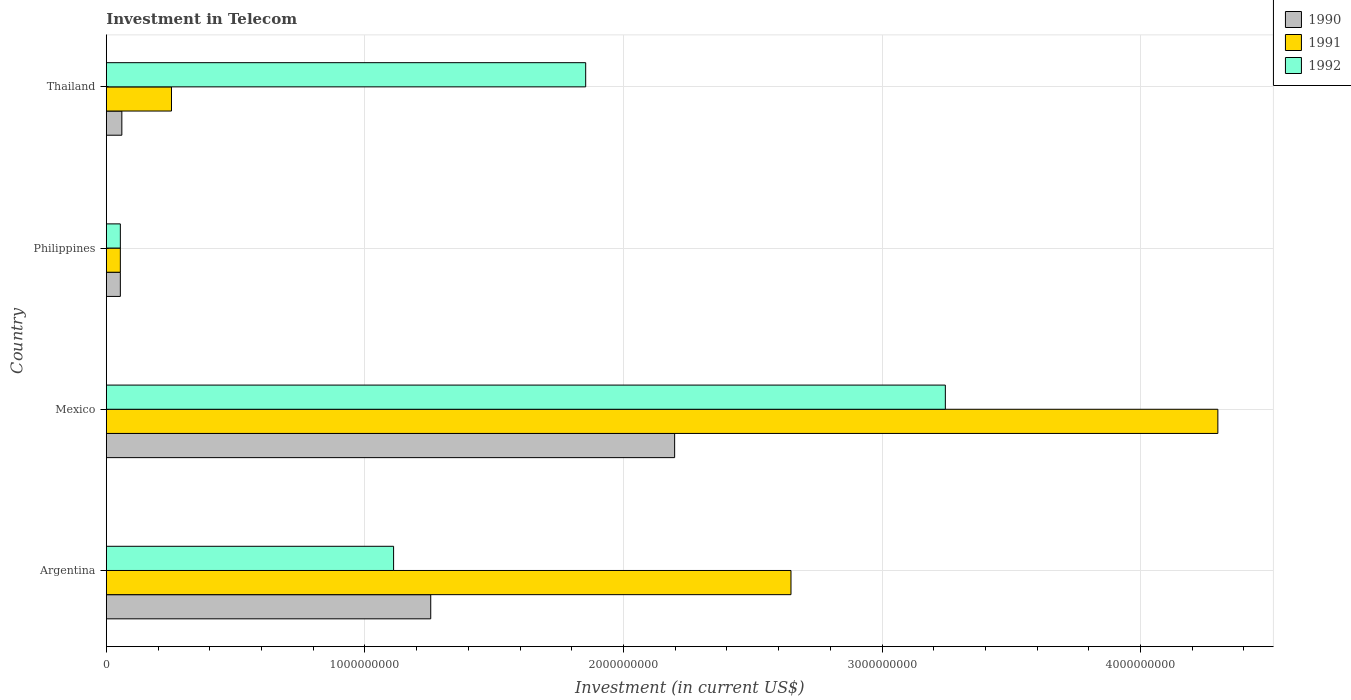How many groups of bars are there?
Your response must be concise. 4. Are the number of bars per tick equal to the number of legend labels?
Keep it short and to the point. Yes. What is the label of the 2nd group of bars from the top?
Provide a succinct answer. Philippines. In how many cases, is the number of bars for a given country not equal to the number of legend labels?
Provide a succinct answer. 0. What is the amount invested in telecom in 1991 in Argentina?
Keep it short and to the point. 2.65e+09. Across all countries, what is the maximum amount invested in telecom in 1992?
Give a very brief answer. 3.24e+09. Across all countries, what is the minimum amount invested in telecom in 1991?
Offer a terse response. 5.42e+07. In which country was the amount invested in telecom in 1990 minimum?
Make the answer very short. Philippines. What is the total amount invested in telecom in 1991 in the graph?
Your answer should be very brief. 7.25e+09. What is the difference between the amount invested in telecom in 1992 in Mexico and that in Thailand?
Offer a terse response. 1.39e+09. What is the difference between the amount invested in telecom in 1992 in Philippines and the amount invested in telecom in 1990 in Mexico?
Offer a terse response. -2.14e+09. What is the average amount invested in telecom in 1992 per country?
Keep it short and to the point. 1.57e+09. What is the difference between the amount invested in telecom in 1990 and amount invested in telecom in 1991 in Thailand?
Offer a very short reply. -1.92e+08. In how many countries, is the amount invested in telecom in 1992 greater than 600000000 US$?
Provide a short and direct response. 3. What is the ratio of the amount invested in telecom in 1990 in Argentina to that in Mexico?
Ensure brevity in your answer.  0.57. Is the amount invested in telecom in 1990 in Mexico less than that in Thailand?
Offer a very short reply. No. What is the difference between the highest and the second highest amount invested in telecom in 1991?
Offer a very short reply. 1.65e+09. What is the difference between the highest and the lowest amount invested in telecom in 1991?
Provide a short and direct response. 4.24e+09. What does the 3rd bar from the bottom in Thailand represents?
Make the answer very short. 1992. Is it the case that in every country, the sum of the amount invested in telecom in 1992 and amount invested in telecom in 1991 is greater than the amount invested in telecom in 1990?
Keep it short and to the point. Yes. Are all the bars in the graph horizontal?
Your answer should be compact. Yes. How many countries are there in the graph?
Keep it short and to the point. 4. What is the difference between two consecutive major ticks on the X-axis?
Your answer should be compact. 1.00e+09. Are the values on the major ticks of X-axis written in scientific E-notation?
Give a very brief answer. No. Does the graph contain grids?
Offer a very short reply. Yes. How are the legend labels stacked?
Your answer should be very brief. Vertical. What is the title of the graph?
Ensure brevity in your answer.  Investment in Telecom. Does "1982" appear as one of the legend labels in the graph?
Your answer should be compact. No. What is the label or title of the X-axis?
Keep it short and to the point. Investment (in current US$). What is the Investment (in current US$) in 1990 in Argentina?
Your response must be concise. 1.25e+09. What is the Investment (in current US$) in 1991 in Argentina?
Make the answer very short. 2.65e+09. What is the Investment (in current US$) of 1992 in Argentina?
Ensure brevity in your answer.  1.11e+09. What is the Investment (in current US$) of 1990 in Mexico?
Make the answer very short. 2.20e+09. What is the Investment (in current US$) of 1991 in Mexico?
Keep it short and to the point. 4.30e+09. What is the Investment (in current US$) of 1992 in Mexico?
Give a very brief answer. 3.24e+09. What is the Investment (in current US$) of 1990 in Philippines?
Provide a short and direct response. 5.42e+07. What is the Investment (in current US$) in 1991 in Philippines?
Provide a short and direct response. 5.42e+07. What is the Investment (in current US$) in 1992 in Philippines?
Your answer should be very brief. 5.42e+07. What is the Investment (in current US$) in 1990 in Thailand?
Offer a very short reply. 6.00e+07. What is the Investment (in current US$) in 1991 in Thailand?
Keep it short and to the point. 2.52e+08. What is the Investment (in current US$) in 1992 in Thailand?
Make the answer very short. 1.85e+09. Across all countries, what is the maximum Investment (in current US$) of 1990?
Your answer should be very brief. 2.20e+09. Across all countries, what is the maximum Investment (in current US$) in 1991?
Keep it short and to the point. 4.30e+09. Across all countries, what is the maximum Investment (in current US$) in 1992?
Make the answer very short. 3.24e+09. Across all countries, what is the minimum Investment (in current US$) in 1990?
Make the answer very short. 5.42e+07. Across all countries, what is the minimum Investment (in current US$) in 1991?
Keep it short and to the point. 5.42e+07. Across all countries, what is the minimum Investment (in current US$) in 1992?
Offer a terse response. 5.42e+07. What is the total Investment (in current US$) in 1990 in the graph?
Give a very brief answer. 3.57e+09. What is the total Investment (in current US$) of 1991 in the graph?
Keep it short and to the point. 7.25e+09. What is the total Investment (in current US$) of 1992 in the graph?
Provide a succinct answer. 6.26e+09. What is the difference between the Investment (in current US$) in 1990 in Argentina and that in Mexico?
Provide a short and direct response. -9.43e+08. What is the difference between the Investment (in current US$) in 1991 in Argentina and that in Mexico?
Ensure brevity in your answer.  -1.65e+09. What is the difference between the Investment (in current US$) in 1992 in Argentina and that in Mexico?
Provide a short and direct response. -2.13e+09. What is the difference between the Investment (in current US$) in 1990 in Argentina and that in Philippines?
Keep it short and to the point. 1.20e+09. What is the difference between the Investment (in current US$) in 1991 in Argentina and that in Philippines?
Offer a terse response. 2.59e+09. What is the difference between the Investment (in current US$) of 1992 in Argentina and that in Philippines?
Your answer should be compact. 1.06e+09. What is the difference between the Investment (in current US$) of 1990 in Argentina and that in Thailand?
Offer a terse response. 1.19e+09. What is the difference between the Investment (in current US$) in 1991 in Argentina and that in Thailand?
Give a very brief answer. 2.40e+09. What is the difference between the Investment (in current US$) of 1992 in Argentina and that in Thailand?
Offer a very short reply. -7.43e+08. What is the difference between the Investment (in current US$) in 1990 in Mexico and that in Philippines?
Your answer should be compact. 2.14e+09. What is the difference between the Investment (in current US$) in 1991 in Mexico and that in Philippines?
Provide a succinct answer. 4.24e+09. What is the difference between the Investment (in current US$) in 1992 in Mexico and that in Philippines?
Your answer should be very brief. 3.19e+09. What is the difference between the Investment (in current US$) of 1990 in Mexico and that in Thailand?
Give a very brief answer. 2.14e+09. What is the difference between the Investment (in current US$) in 1991 in Mexico and that in Thailand?
Keep it short and to the point. 4.05e+09. What is the difference between the Investment (in current US$) of 1992 in Mexico and that in Thailand?
Your response must be concise. 1.39e+09. What is the difference between the Investment (in current US$) of 1990 in Philippines and that in Thailand?
Offer a very short reply. -5.80e+06. What is the difference between the Investment (in current US$) in 1991 in Philippines and that in Thailand?
Your answer should be very brief. -1.98e+08. What is the difference between the Investment (in current US$) in 1992 in Philippines and that in Thailand?
Your answer should be very brief. -1.80e+09. What is the difference between the Investment (in current US$) of 1990 in Argentina and the Investment (in current US$) of 1991 in Mexico?
Ensure brevity in your answer.  -3.04e+09. What is the difference between the Investment (in current US$) in 1990 in Argentina and the Investment (in current US$) in 1992 in Mexico?
Ensure brevity in your answer.  -1.99e+09. What is the difference between the Investment (in current US$) of 1991 in Argentina and the Investment (in current US$) of 1992 in Mexico?
Offer a terse response. -5.97e+08. What is the difference between the Investment (in current US$) in 1990 in Argentina and the Investment (in current US$) in 1991 in Philippines?
Offer a very short reply. 1.20e+09. What is the difference between the Investment (in current US$) in 1990 in Argentina and the Investment (in current US$) in 1992 in Philippines?
Your answer should be very brief. 1.20e+09. What is the difference between the Investment (in current US$) in 1991 in Argentina and the Investment (in current US$) in 1992 in Philippines?
Give a very brief answer. 2.59e+09. What is the difference between the Investment (in current US$) in 1990 in Argentina and the Investment (in current US$) in 1991 in Thailand?
Ensure brevity in your answer.  1.00e+09. What is the difference between the Investment (in current US$) in 1990 in Argentina and the Investment (in current US$) in 1992 in Thailand?
Your answer should be compact. -5.99e+08. What is the difference between the Investment (in current US$) of 1991 in Argentina and the Investment (in current US$) of 1992 in Thailand?
Ensure brevity in your answer.  7.94e+08. What is the difference between the Investment (in current US$) in 1990 in Mexico and the Investment (in current US$) in 1991 in Philippines?
Provide a short and direct response. 2.14e+09. What is the difference between the Investment (in current US$) of 1990 in Mexico and the Investment (in current US$) of 1992 in Philippines?
Ensure brevity in your answer.  2.14e+09. What is the difference between the Investment (in current US$) of 1991 in Mexico and the Investment (in current US$) of 1992 in Philippines?
Provide a short and direct response. 4.24e+09. What is the difference between the Investment (in current US$) of 1990 in Mexico and the Investment (in current US$) of 1991 in Thailand?
Make the answer very short. 1.95e+09. What is the difference between the Investment (in current US$) of 1990 in Mexico and the Investment (in current US$) of 1992 in Thailand?
Provide a succinct answer. 3.44e+08. What is the difference between the Investment (in current US$) in 1991 in Mexico and the Investment (in current US$) in 1992 in Thailand?
Provide a short and direct response. 2.44e+09. What is the difference between the Investment (in current US$) of 1990 in Philippines and the Investment (in current US$) of 1991 in Thailand?
Your answer should be very brief. -1.98e+08. What is the difference between the Investment (in current US$) of 1990 in Philippines and the Investment (in current US$) of 1992 in Thailand?
Keep it short and to the point. -1.80e+09. What is the difference between the Investment (in current US$) of 1991 in Philippines and the Investment (in current US$) of 1992 in Thailand?
Ensure brevity in your answer.  -1.80e+09. What is the average Investment (in current US$) of 1990 per country?
Ensure brevity in your answer.  8.92e+08. What is the average Investment (in current US$) of 1991 per country?
Your response must be concise. 1.81e+09. What is the average Investment (in current US$) in 1992 per country?
Provide a short and direct response. 1.57e+09. What is the difference between the Investment (in current US$) of 1990 and Investment (in current US$) of 1991 in Argentina?
Offer a terse response. -1.39e+09. What is the difference between the Investment (in current US$) in 1990 and Investment (in current US$) in 1992 in Argentina?
Provide a short and direct response. 1.44e+08. What is the difference between the Investment (in current US$) in 1991 and Investment (in current US$) in 1992 in Argentina?
Provide a succinct answer. 1.54e+09. What is the difference between the Investment (in current US$) of 1990 and Investment (in current US$) of 1991 in Mexico?
Give a very brief answer. -2.10e+09. What is the difference between the Investment (in current US$) of 1990 and Investment (in current US$) of 1992 in Mexico?
Offer a terse response. -1.05e+09. What is the difference between the Investment (in current US$) in 1991 and Investment (in current US$) in 1992 in Mexico?
Your response must be concise. 1.05e+09. What is the difference between the Investment (in current US$) in 1990 and Investment (in current US$) in 1991 in Philippines?
Give a very brief answer. 0. What is the difference between the Investment (in current US$) in 1990 and Investment (in current US$) in 1992 in Philippines?
Make the answer very short. 0. What is the difference between the Investment (in current US$) of 1990 and Investment (in current US$) of 1991 in Thailand?
Give a very brief answer. -1.92e+08. What is the difference between the Investment (in current US$) in 1990 and Investment (in current US$) in 1992 in Thailand?
Offer a very short reply. -1.79e+09. What is the difference between the Investment (in current US$) in 1991 and Investment (in current US$) in 1992 in Thailand?
Offer a very short reply. -1.60e+09. What is the ratio of the Investment (in current US$) in 1990 in Argentina to that in Mexico?
Provide a succinct answer. 0.57. What is the ratio of the Investment (in current US$) of 1991 in Argentina to that in Mexico?
Keep it short and to the point. 0.62. What is the ratio of the Investment (in current US$) in 1992 in Argentina to that in Mexico?
Provide a short and direct response. 0.34. What is the ratio of the Investment (in current US$) in 1990 in Argentina to that in Philippines?
Your response must be concise. 23.15. What is the ratio of the Investment (in current US$) in 1991 in Argentina to that in Philippines?
Your response must be concise. 48.86. What is the ratio of the Investment (in current US$) of 1992 in Argentina to that in Philippines?
Ensure brevity in your answer.  20.5. What is the ratio of the Investment (in current US$) in 1990 in Argentina to that in Thailand?
Your response must be concise. 20.91. What is the ratio of the Investment (in current US$) in 1991 in Argentina to that in Thailand?
Keep it short and to the point. 10.51. What is the ratio of the Investment (in current US$) of 1992 in Argentina to that in Thailand?
Ensure brevity in your answer.  0.6. What is the ratio of the Investment (in current US$) of 1990 in Mexico to that in Philippines?
Offer a very short reply. 40.55. What is the ratio of the Investment (in current US$) of 1991 in Mexico to that in Philippines?
Your answer should be very brief. 79.32. What is the ratio of the Investment (in current US$) in 1992 in Mexico to that in Philippines?
Make the answer very short. 59.87. What is the ratio of the Investment (in current US$) of 1990 in Mexico to that in Thailand?
Your answer should be very brief. 36.63. What is the ratio of the Investment (in current US$) of 1991 in Mexico to that in Thailand?
Ensure brevity in your answer.  17.06. What is the ratio of the Investment (in current US$) in 1992 in Mexico to that in Thailand?
Provide a succinct answer. 1.75. What is the ratio of the Investment (in current US$) in 1990 in Philippines to that in Thailand?
Your answer should be very brief. 0.9. What is the ratio of the Investment (in current US$) of 1991 in Philippines to that in Thailand?
Give a very brief answer. 0.22. What is the ratio of the Investment (in current US$) of 1992 in Philippines to that in Thailand?
Offer a terse response. 0.03. What is the difference between the highest and the second highest Investment (in current US$) of 1990?
Give a very brief answer. 9.43e+08. What is the difference between the highest and the second highest Investment (in current US$) of 1991?
Offer a very short reply. 1.65e+09. What is the difference between the highest and the second highest Investment (in current US$) in 1992?
Make the answer very short. 1.39e+09. What is the difference between the highest and the lowest Investment (in current US$) in 1990?
Give a very brief answer. 2.14e+09. What is the difference between the highest and the lowest Investment (in current US$) in 1991?
Your answer should be compact. 4.24e+09. What is the difference between the highest and the lowest Investment (in current US$) in 1992?
Offer a very short reply. 3.19e+09. 